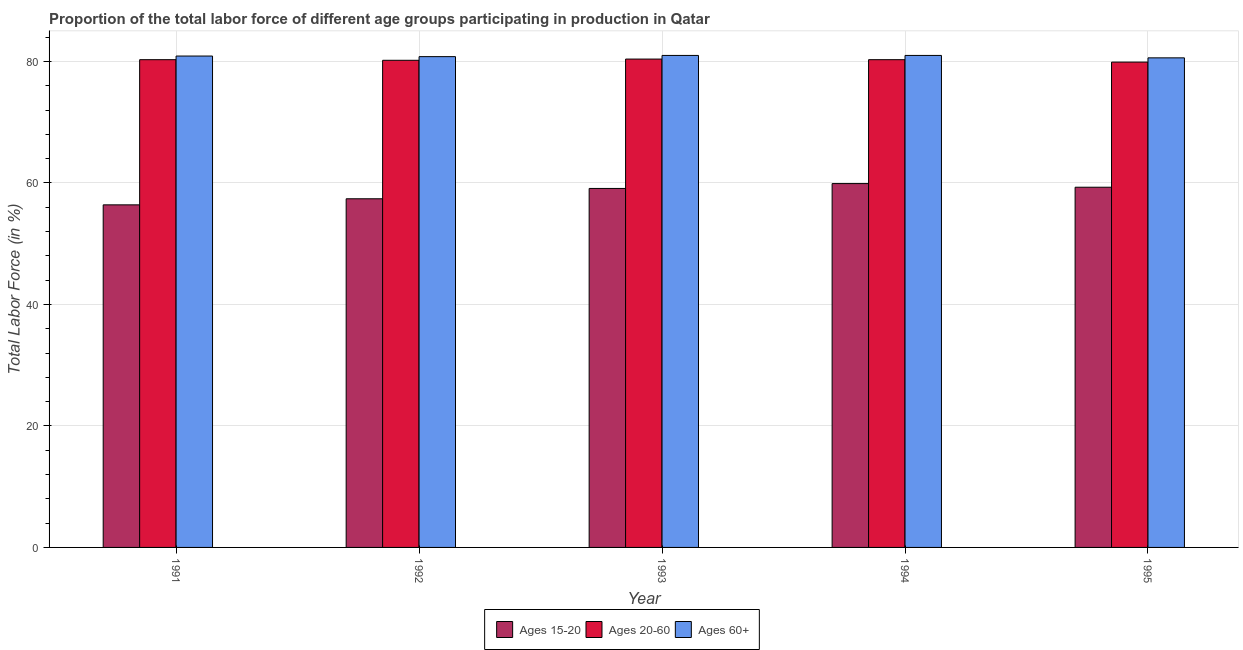How many different coloured bars are there?
Offer a terse response. 3. How many groups of bars are there?
Offer a very short reply. 5. Are the number of bars per tick equal to the number of legend labels?
Provide a succinct answer. Yes. Are the number of bars on each tick of the X-axis equal?
Offer a terse response. Yes. How many bars are there on the 2nd tick from the right?
Your answer should be compact. 3. What is the label of the 5th group of bars from the left?
Provide a short and direct response. 1995. What is the percentage of labor force within the age group 15-20 in 1993?
Provide a short and direct response. 59.1. Across all years, what is the maximum percentage of labor force above age 60?
Keep it short and to the point. 81. Across all years, what is the minimum percentage of labor force above age 60?
Ensure brevity in your answer.  80.6. In which year was the percentage of labor force within the age group 20-60 minimum?
Offer a very short reply. 1995. What is the total percentage of labor force above age 60 in the graph?
Provide a succinct answer. 404.3. What is the difference between the percentage of labor force within the age group 20-60 in 1994 and that in 1995?
Provide a succinct answer. 0.4. What is the difference between the percentage of labor force within the age group 15-20 in 1995 and the percentage of labor force within the age group 20-60 in 1994?
Offer a terse response. -0.6. What is the average percentage of labor force within the age group 20-60 per year?
Your answer should be compact. 80.22. In the year 1995, what is the difference between the percentage of labor force within the age group 20-60 and percentage of labor force within the age group 15-20?
Provide a short and direct response. 0. What is the ratio of the percentage of labor force within the age group 15-20 in 1993 to that in 1994?
Provide a succinct answer. 0.99. Is the difference between the percentage of labor force above age 60 in 1992 and 1993 greater than the difference between the percentage of labor force within the age group 20-60 in 1992 and 1993?
Keep it short and to the point. No. What is the difference between the highest and the second highest percentage of labor force within the age group 20-60?
Offer a terse response. 0.1. What does the 1st bar from the left in 1994 represents?
Ensure brevity in your answer.  Ages 15-20. What does the 3rd bar from the right in 1994 represents?
Your answer should be compact. Ages 15-20. Is it the case that in every year, the sum of the percentage of labor force within the age group 15-20 and percentage of labor force within the age group 20-60 is greater than the percentage of labor force above age 60?
Your answer should be very brief. Yes. How many years are there in the graph?
Ensure brevity in your answer.  5. Does the graph contain grids?
Make the answer very short. Yes. What is the title of the graph?
Your answer should be very brief. Proportion of the total labor force of different age groups participating in production in Qatar. What is the label or title of the Y-axis?
Ensure brevity in your answer.  Total Labor Force (in %). What is the Total Labor Force (in %) of Ages 15-20 in 1991?
Your response must be concise. 56.4. What is the Total Labor Force (in %) of Ages 20-60 in 1991?
Ensure brevity in your answer.  80.3. What is the Total Labor Force (in %) of Ages 60+ in 1991?
Make the answer very short. 80.9. What is the Total Labor Force (in %) in Ages 15-20 in 1992?
Provide a short and direct response. 57.4. What is the Total Labor Force (in %) of Ages 20-60 in 1992?
Your answer should be compact. 80.2. What is the Total Labor Force (in %) in Ages 60+ in 1992?
Offer a terse response. 80.8. What is the Total Labor Force (in %) of Ages 15-20 in 1993?
Ensure brevity in your answer.  59.1. What is the Total Labor Force (in %) in Ages 20-60 in 1993?
Your answer should be very brief. 80.4. What is the Total Labor Force (in %) of Ages 15-20 in 1994?
Offer a very short reply. 59.9. What is the Total Labor Force (in %) in Ages 20-60 in 1994?
Your response must be concise. 80.3. What is the Total Labor Force (in %) of Ages 60+ in 1994?
Offer a very short reply. 81. What is the Total Labor Force (in %) of Ages 15-20 in 1995?
Your response must be concise. 59.3. What is the Total Labor Force (in %) of Ages 20-60 in 1995?
Ensure brevity in your answer.  79.9. What is the Total Labor Force (in %) in Ages 60+ in 1995?
Offer a very short reply. 80.6. Across all years, what is the maximum Total Labor Force (in %) of Ages 15-20?
Provide a succinct answer. 59.9. Across all years, what is the maximum Total Labor Force (in %) of Ages 20-60?
Offer a terse response. 80.4. Across all years, what is the minimum Total Labor Force (in %) in Ages 15-20?
Make the answer very short. 56.4. Across all years, what is the minimum Total Labor Force (in %) in Ages 20-60?
Give a very brief answer. 79.9. Across all years, what is the minimum Total Labor Force (in %) of Ages 60+?
Ensure brevity in your answer.  80.6. What is the total Total Labor Force (in %) of Ages 15-20 in the graph?
Provide a succinct answer. 292.1. What is the total Total Labor Force (in %) in Ages 20-60 in the graph?
Ensure brevity in your answer.  401.1. What is the total Total Labor Force (in %) in Ages 60+ in the graph?
Provide a short and direct response. 404.3. What is the difference between the Total Labor Force (in %) of Ages 15-20 in 1991 and that in 1992?
Give a very brief answer. -1. What is the difference between the Total Labor Force (in %) of Ages 20-60 in 1991 and that in 1992?
Ensure brevity in your answer.  0.1. What is the difference between the Total Labor Force (in %) of Ages 15-20 in 1991 and that in 1993?
Offer a very short reply. -2.7. What is the difference between the Total Labor Force (in %) of Ages 20-60 in 1991 and that in 1993?
Your response must be concise. -0.1. What is the difference between the Total Labor Force (in %) in Ages 15-20 in 1991 and that in 1994?
Provide a short and direct response. -3.5. What is the difference between the Total Labor Force (in %) of Ages 20-60 in 1991 and that in 1994?
Ensure brevity in your answer.  0. What is the difference between the Total Labor Force (in %) in Ages 15-20 in 1991 and that in 1995?
Provide a short and direct response. -2.9. What is the difference between the Total Labor Force (in %) of Ages 60+ in 1992 and that in 1993?
Your answer should be very brief. -0.2. What is the difference between the Total Labor Force (in %) of Ages 15-20 in 1992 and that in 1994?
Provide a short and direct response. -2.5. What is the difference between the Total Labor Force (in %) in Ages 20-60 in 1992 and that in 1995?
Provide a short and direct response. 0.3. What is the difference between the Total Labor Force (in %) of Ages 15-20 in 1993 and that in 1994?
Your response must be concise. -0.8. What is the difference between the Total Labor Force (in %) of Ages 60+ in 1993 and that in 1994?
Give a very brief answer. 0. What is the difference between the Total Labor Force (in %) in Ages 20-60 in 1993 and that in 1995?
Ensure brevity in your answer.  0.5. What is the difference between the Total Labor Force (in %) of Ages 60+ in 1993 and that in 1995?
Provide a succinct answer. 0.4. What is the difference between the Total Labor Force (in %) of Ages 20-60 in 1994 and that in 1995?
Provide a short and direct response. 0.4. What is the difference between the Total Labor Force (in %) in Ages 60+ in 1994 and that in 1995?
Make the answer very short. 0.4. What is the difference between the Total Labor Force (in %) of Ages 15-20 in 1991 and the Total Labor Force (in %) of Ages 20-60 in 1992?
Offer a very short reply. -23.8. What is the difference between the Total Labor Force (in %) in Ages 15-20 in 1991 and the Total Labor Force (in %) in Ages 60+ in 1992?
Your response must be concise. -24.4. What is the difference between the Total Labor Force (in %) in Ages 15-20 in 1991 and the Total Labor Force (in %) in Ages 60+ in 1993?
Your answer should be very brief. -24.6. What is the difference between the Total Labor Force (in %) of Ages 20-60 in 1991 and the Total Labor Force (in %) of Ages 60+ in 1993?
Your answer should be compact. -0.7. What is the difference between the Total Labor Force (in %) of Ages 15-20 in 1991 and the Total Labor Force (in %) of Ages 20-60 in 1994?
Offer a very short reply. -23.9. What is the difference between the Total Labor Force (in %) in Ages 15-20 in 1991 and the Total Labor Force (in %) in Ages 60+ in 1994?
Make the answer very short. -24.6. What is the difference between the Total Labor Force (in %) in Ages 20-60 in 1991 and the Total Labor Force (in %) in Ages 60+ in 1994?
Give a very brief answer. -0.7. What is the difference between the Total Labor Force (in %) of Ages 15-20 in 1991 and the Total Labor Force (in %) of Ages 20-60 in 1995?
Make the answer very short. -23.5. What is the difference between the Total Labor Force (in %) of Ages 15-20 in 1991 and the Total Labor Force (in %) of Ages 60+ in 1995?
Your answer should be very brief. -24.2. What is the difference between the Total Labor Force (in %) in Ages 15-20 in 1992 and the Total Labor Force (in %) in Ages 20-60 in 1993?
Your response must be concise. -23. What is the difference between the Total Labor Force (in %) of Ages 15-20 in 1992 and the Total Labor Force (in %) of Ages 60+ in 1993?
Your answer should be very brief. -23.6. What is the difference between the Total Labor Force (in %) of Ages 20-60 in 1992 and the Total Labor Force (in %) of Ages 60+ in 1993?
Provide a short and direct response. -0.8. What is the difference between the Total Labor Force (in %) in Ages 15-20 in 1992 and the Total Labor Force (in %) in Ages 20-60 in 1994?
Provide a short and direct response. -22.9. What is the difference between the Total Labor Force (in %) of Ages 15-20 in 1992 and the Total Labor Force (in %) of Ages 60+ in 1994?
Provide a succinct answer. -23.6. What is the difference between the Total Labor Force (in %) in Ages 20-60 in 1992 and the Total Labor Force (in %) in Ages 60+ in 1994?
Your answer should be compact. -0.8. What is the difference between the Total Labor Force (in %) in Ages 15-20 in 1992 and the Total Labor Force (in %) in Ages 20-60 in 1995?
Ensure brevity in your answer.  -22.5. What is the difference between the Total Labor Force (in %) in Ages 15-20 in 1992 and the Total Labor Force (in %) in Ages 60+ in 1995?
Your answer should be very brief. -23.2. What is the difference between the Total Labor Force (in %) of Ages 15-20 in 1993 and the Total Labor Force (in %) of Ages 20-60 in 1994?
Ensure brevity in your answer.  -21.2. What is the difference between the Total Labor Force (in %) of Ages 15-20 in 1993 and the Total Labor Force (in %) of Ages 60+ in 1994?
Provide a short and direct response. -21.9. What is the difference between the Total Labor Force (in %) of Ages 20-60 in 1993 and the Total Labor Force (in %) of Ages 60+ in 1994?
Your response must be concise. -0.6. What is the difference between the Total Labor Force (in %) in Ages 15-20 in 1993 and the Total Labor Force (in %) in Ages 20-60 in 1995?
Make the answer very short. -20.8. What is the difference between the Total Labor Force (in %) in Ages 15-20 in 1993 and the Total Labor Force (in %) in Ages 60+ in 1995?
Offer a terse response. -21.5. What is the difference between the Total Labor Force (in %) in Ages 15-20 in 1994 and the Total Labor Force (in %) in Ages 60+ in 1995?
Keep it short and to the point. -20.7. What is the average Total Labor Force (in %) in Ages 15-20 per year?
Your answer should be compact. 58.42. What is the average Total Labor Force (in %) in Ages 20-60 per year?
Provide a short and direct response. 80.22. What is the average Total Labor Force (in %) in Ages 60+ per year?
Your answer should be very brief. 80.86. In the year 1991, what is the difference between the Total Labor Force (in %) in Ages 15-20 and Total Labor Force (in %) in Ages 20-60?
Give a very brief answer. -23.9. In the year 1991, what is the difference between the Total Labor Force (in %) of Ages 15-20 and Total Labor Force (in %) of Ages 60+?
Make the answer very short. -24.5. In the year 1991, what is the difference between the Total Labor Force (in %) in Ages 20-60 and Total Labor Force (in %) in Ages 60+?
Offer a terse response. -0.6. In the year 1992, what is the difference between the Total Labor Force (in %) in Ages 15-20 and Total Labor Force (in %) in Ages 20-60?
Provide a succinct answer. -22.8. In the year 1992, what is the difference between the Total Labor Force (in %) of Ages 15-20 and Total Labor Force (in %) of Ages 60+?
Provide a short and direct response. -23.4. In the year 1993, what is the difference between the Total Labor Force (in %) in Ages 15-20 and Total Labor Force (in %) in Ages 20-60?
Provide a short and direct response. -21.3. In the year 1993, what is the difference between the Total Labor Force (in %) of Ages 15-20 and Total Labor Force (in %) of Ages 60+?
Your answer should be compact. -21.9. In the year 1993, what is the difference between the Total Labor Force (in %) in Ages 20-60 and Total Labor Force (in %) in Ages 60+?
Provide a short and direct response. -0.6. In the year 1994, what is the difference between the Total Labor Force (in %) of Ages 15-20 and Total Labor Force (in %) of Ages 20-60?
Keep it short and to the point. -20.4. In the year 1994, what is the difference between the Total Labor Force (in %) in Ages 15-20 and Total Labor Force (in %) in Ages 60+?
Offer a terse response. -21.1. In the year 1995, what is the difference between the Total Labor Force (in %) in Ages 15-20 and Total Labor Force (in %) in Ages 20-60?
Provide a succinct answer. -20.6. In the year 1995, what is the difference between the Total Labor Force (in %) of Ages 15-20 and Total Labor Force (in %) of Ages 60+?
Keep it short and to the point. -21.3. In the year 1995, what is the difference between the Total Labor Force (in %) in Ages 20-60 and Total Labor Force (in %) in Ages 60+?
Make the answer very short. -0.7. What is the ratio of the Total Labor Force (in %) of Ages 15-20 in 1991 to that in 1992?
Your response must be concise. 0.98. What is the ratio of the Total Labor Force (in %) of Ages 20-60 in 1991 to that in 1992?
Provide a short and direct response. 1. What is the ratio of the Total Labor Force (in %) in Ages 60+ in 1991 to that in 1992?
Your answer should be compact. 1. What is the ratio of the Total Labor Force (in %) of Ages 15-20 in 1991 to that in 1993?
Provide a short and direct response. 0.95. What is the ratio of the Total Labor Force (in %) of Ages 20-60 in 1991 to that in 1993?
Your answer should be compact. 1. What is the ratio of the Total Labor Force (in %) in Ages 15-20 in 1991 to that in 1994?
Provide a short and direct response. 0.94. What is the ratio of the Total Labor Force (in %) in Ages 60+ in 1991 to that in 1994?
Provide a succinct answer. 1. What is the ratio of the Total Labor Force (in %) of Ages 15-20 in 1991 to that in 1995?
Make the answer very short. 0.95. What is the ratio of the Total Labor Force (in %) in Ages 60+ in 1991 to that in 1995?
Offer a very short reply. 1. What is the ratio of the Total Labor Force (in %) of Ages 15-20 in 1992 to that in 1993?
Make the answer very short. 0.97. What is the ratio of the Total Labor Force (in %) of Ages 20-60 in 1992 to that in 1993?
Provide a short and direct response. 1. What is the ratio of the Total Labor Force (in %) in Ages 60+ in 1992 to that in 1993?
Give a very brief answer. 1. What is the ratio of the Total Labor Force (in %) in Ages 20-60 in 1992 to that in 1994?
Your answer should be very brief. 1. What is the ratio of the Total Labor Force (in %) in Ages 15-20 in 1992 to that in 1995?
Your answer should be very brief. 0.97. What is the ratio of the Total Labor Force (in %) of Ages 20-60 in 1992 to that in 1995?
Offer a terse response. 1. What is the ratio of the Total Labor Force (in %) of Ages 15-20 in 1993 to that in 1994?
Provide a short and direct response. 0.99. What is the ratio of the Total Labor Force (in %) of Ages 60+ in 1993 to that in 1994?
Provide a succinct answer. 1. What is the ratio of the Total Labor Force (in %) in Ages 15-20 in 1994 to that in 1995?
Provide a short and direct response. 1.01. What is the ratio of the Total Labor Force (in %) in Ages 60+ in 1994 to that in 1995?
Provide a short and direct response. 1. What is the difference between the highest and the second highest Total Labor Force (in %) of Ages 20-60?
Ensure brevity in your answer.  0.1. 